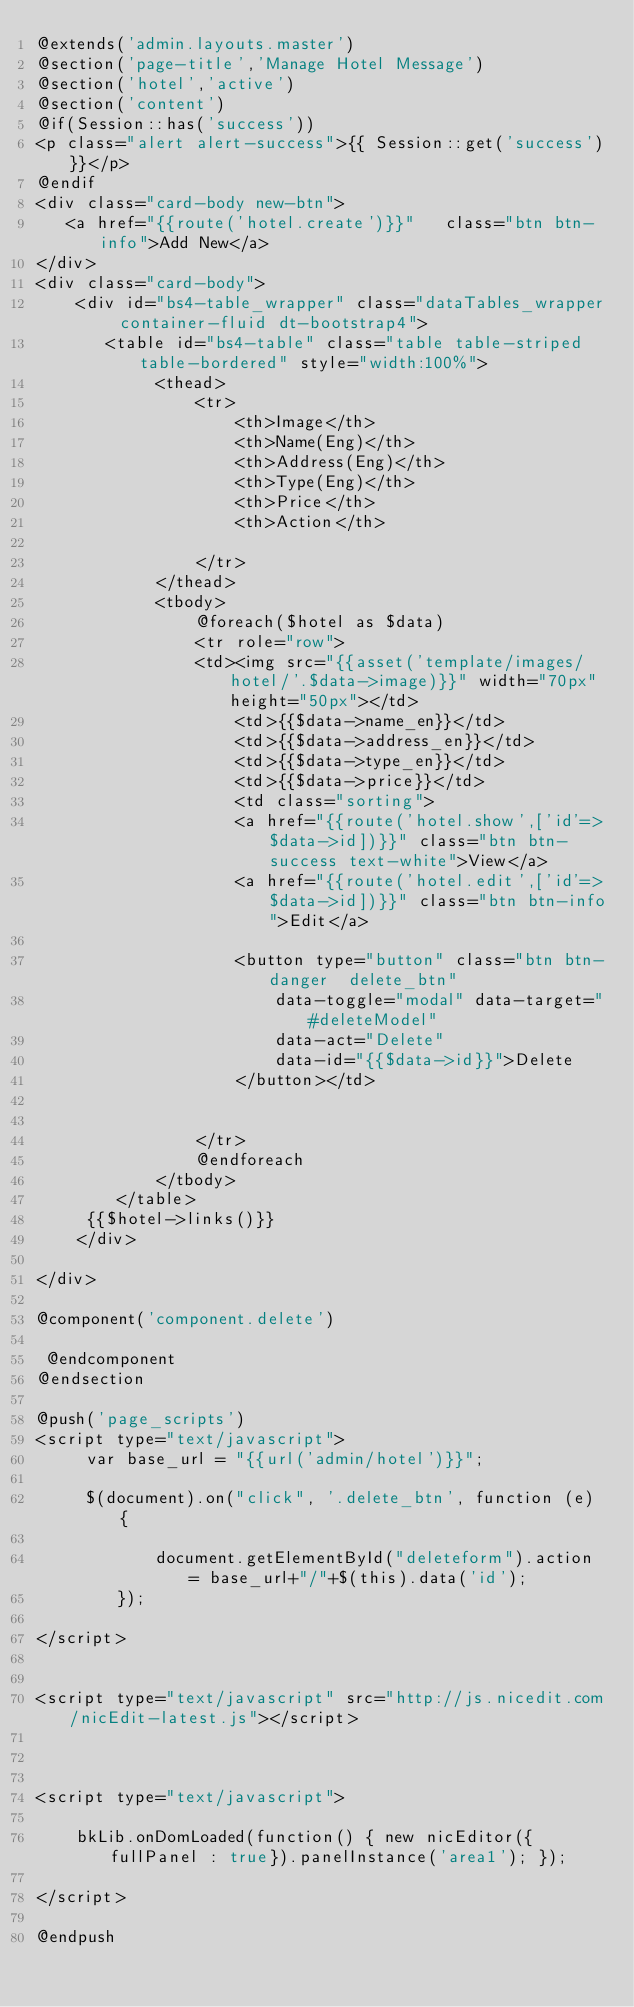<code> <loc_0><loc_0><loc_500><loc_500><_PHP_>@extends('admin.layouts.master')
@section('page-title','Manage Hotel Message')
@section('hotel','active')
@section('content')
@if(Session::has('success'))
<p class="alert alert-success">{{ Session::get('success')}}</p>
@endif
<div class="card-body new-btn">
   <a href="{{route('hotel.create')}}"   class="btn btn-info">Add New</a>
</div>
<div class="card-body">
    <div id="bs4-table_wrapper" class="dataTables_wrapper container-fluid dt-bootstrap4">
       <table id="bs4-table" class="table table-striped table-bordered" style="width:100%">
            <thead>
                <tr>
                    <th>Image</th>
                    <th>Name(Eng)</th>                    
                    <th>Address(Eng)</th>                  
                    <th>Type(Eng)</th>                    
                    <th>Price</th>
                    <th>Action</th>
                    
                </tr>
            </thead>
            <tbody>
                @foreach($hotel as $data)
                <tr role="row">
                <td><img src="{{asset('template/images/hotel/'.$data->image)}}" width="70px" height="50px"></td>
                    <td>{{$data->name_en}}</td>                    
                    <td>{{$data->address_en}}</td>             
                    <td>{{$data->type_en}}</td>                    
                    <td>{{$data->price}}</td>
                    <td class="sorting">
                    <a href="{{route('hotel.show',['id'=>$data->id])}}" class="btn btn-success text-white">View</a>   
                    <a href="{{route('hotel.edit',['id'=>$data->id])}}" class="btn btn-info">Edit</a>
                         
                    <button type="button" class="btn btn-danger  delete_btn"
                        data-toggle="modal" data-target="#deleteModel"
                        data-act="Delete"
                        data-id="{{$data->id}}">Delete
                    </button></td>
                    
                    
                </tr>
                @endforeach
            </tbody>
        </table>
     {{$hotel->links()}}  
    </div>
   
</div>

@component('component.delete')

 @endcomponent
@endsection

@push('page_scripts')
<script type="text/javascript">
     var base_url = "{{url('admin/hotel')}}";
      
     $(document).on("click", '.delete_btn', function (e) {  
            
            document.getElementById("deleteform").action = base_url+"/"+$(this).data('id');
        });
   
</script>


<script type="text/javascript" src="http://js.nicedit.com/nicEdit-latest.js"></script>



<script type="text/javascript">

    bkLib.onDomLoaded(function() { new nicEditor({fullPanel : true}).panelInstance('area1'); });

</script>

@endpush




</code> 